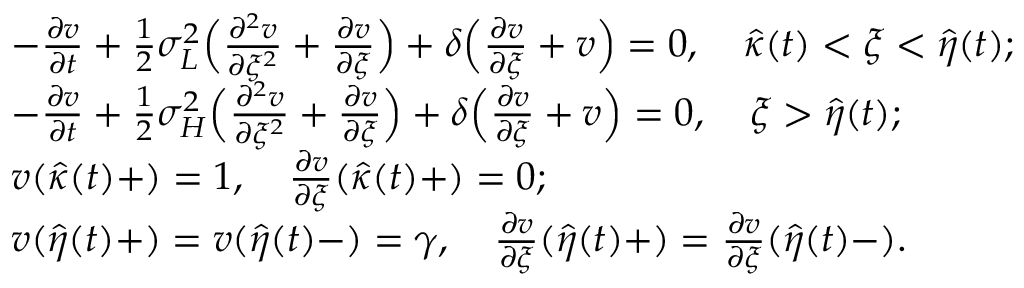Convert formula to latex. <formula><loc_0><loc_0><loc_500><loc_500>\begin{array} { r l } & { - \frac { \partial v } { \partial t } + \frac { 1 } { 2 } \sigma _ { L } ^ { 2 } \left ( \frac { \partial ^ { 2 } v } { \partial \xi ^ { 2 } } + \frac { \partial v } { \partial \xi } \right ) + \delta \left ( \frac { \partial v } { \partial \xi } + v \right ) = 0 , \quad \hat { \kappa } ( t ) < \xi < \hat { \eta } ( t ) ; } \\ & { - \frac { \partial v } { \partial t } + \frac { 1 } { 2 } \sigma _ { H } ^ { 2 } \left ( \frac { \partial ^ { 2 } v } { \partial \xi ^ { 2 } } + \frac { \partial v } { \partial \xi } \right ) + \delta \left ( \frac { \partial v } { \partial \xi } + v \right ) = 0 , \quad \xi > \hat { \eta } ( t ) ; } \\ & { v ( \hat { \kappa } ( t ) + ) = 1 , \quad \frac { \partial v } { \partial \xi } ( \hat { \kappa } ( t ) + ) = 0 ; } \\ & { v ( \hat { \eta } ( t ) + ) = v ( \hat { \eta } ( t ) - ) = \gamma , \quad \frac { \partial v } { \partial \xi } ( \hat { \eta } ( t ) + ) = \frac { \partial v } { \partial \xi } ( \hat { \eta } ( t ) - ) . } \end{array}</formula> 